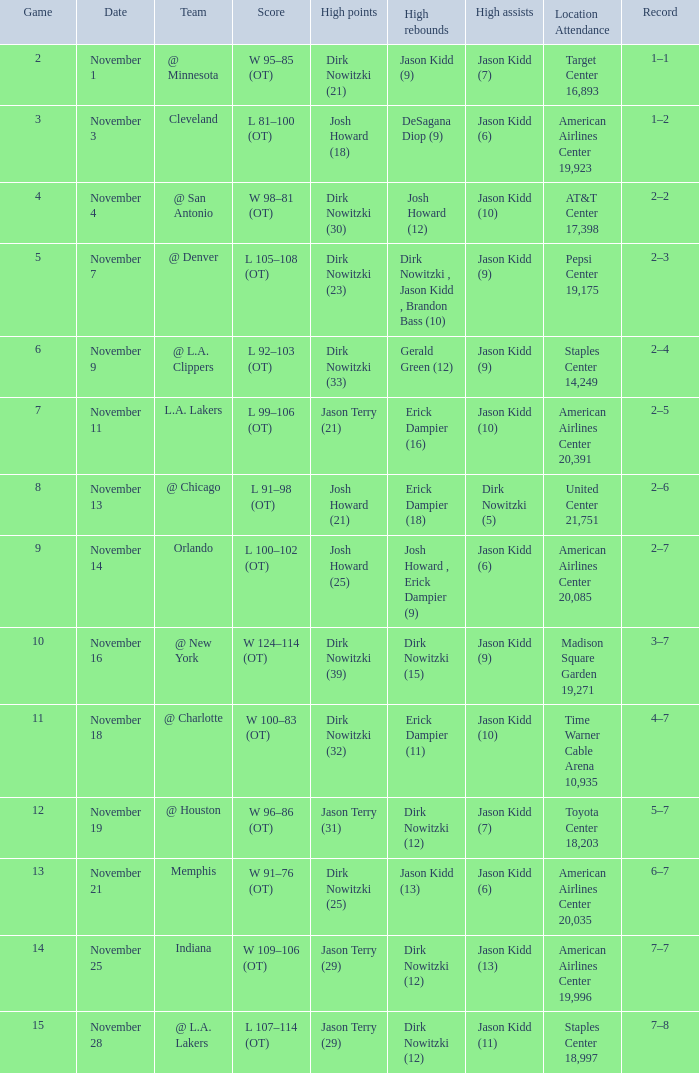Parse the table in full. {'header': ['Game', 'Date', 'Team', 'Score', 'High points', 'High rebounds', 'High assists', 'Location Attendance', 'Record'], 'rows': [['2', 'November 1', '@ Minnesota', 'W 95–85 (OT)', 'Dirk Nowitzki (21)', 'Jason Kidd (9)', 'Jason Kidd (7)', 'Target Center 16,893', '1–1'], ['3', 'November 3', 'Cleveland', 'L 81–100 (OT)', 'Josh Howard (18)', 'DeSagana Diop (9)', 'Jason Kidd (6)', 'American Airlines Center 19,923', '1–2'], ['4', 'November 4', '@ San Antonio', 'W 98–81 (OT)', 'Dirk Nowitzki (30)', 'Josh Howard (12)', 'Jason Kidd (10)', 'AT&T Center 17,398', '2–2'], ['5', 'November 7', '@ Denver', 'L 105–108 (OT)', 'Dirk Nowitzki (23)', 'Dirk Nowitzki , Jason Kidd , Brandon Bass (10)', 'Jason Kidd (9)', 'Pepsi Center 19,175', '2–3'], ['6', 'November 9', '@ L.A. Clippers', 'L 92–103 (OT)', 'Dirk Nowitzki (33)', 'Gerald Green (12)', 'Jason Kidd (9)', 'Staples Center 14,249', '2–4'], ['7', 'November 11', 'L.A. Lakers', 'L 99–106 (OT)', 'Jason Terry (21)', 'Erick Dampier (16)', 'Jason Kidd (10)', 'American Airlines Center 20,391', '2–5'], ['8', 'November 13', '@ Chicago', 'L 91–98 (OT)', 'Josh Howard (21)', 'Erick Dampier (18)', 'Dirk Nowitzki (5)', 'United Center 21,751', '2–6'], ['9', 'November 14', 'Orlando', 'L 100–102 (OT)', 'Josh Howard (25)', 'Josh Howard , Erick Dampier (9)', 'Jason Kidd (6)', 'American Airlines Center 20,085', '2–7'], ['10', 'November 16', '@ New York', 'W 124–114 (OT)', 'Dirk Nowitzki (39)', 'Dirk Nowitzki (15)', 'Jason Kidd (9)', 'Madison Square Garden 19,271', '3–7'], ['11', 'November 18', '@ Charlotte', 'W 100–83 (OT)', 'Dirk Nowitzki (32)', 'Erick Dampier (11)', 'Jason Kidd (10)', 'Time Warner Cable Arena 10,935', '4–7'], ['12', 'November 19', '@ Houston', 'W 96–86 (OT)', 'Jason Terry (31)', 'Dirk Nowitzki (12)', 'Jason Kidd (7)', 'Toyota Center 18,203', '5–7'], ['13', 'November 21', 'Memphis', 'W 91–76 (OT)', 'Dirk Nowitzki (25)', 'Jason Kidd (13)', 'Jason Kidd (6)', 'American Airlines Center 20,035', '6–7'], ['14', 'November 25', 'Indiana', 'W 109–106 (OT)', 'Jason Terry (29)', 'Dirk Nowitzki (12)', 'Jason Kidd (13)', 'American Airlines Center 19,996', '7–7'], ['15', 'November 28', '@ L.A. Lakers', 'L 107–114 (OT)', 'Jason Terry (29)', 'Dirk Nowitzki (12)', 'Jason Kidd (11)', 'Staples Center 18,997', '7–8']]} What was the status on november 1st? 1–1. 